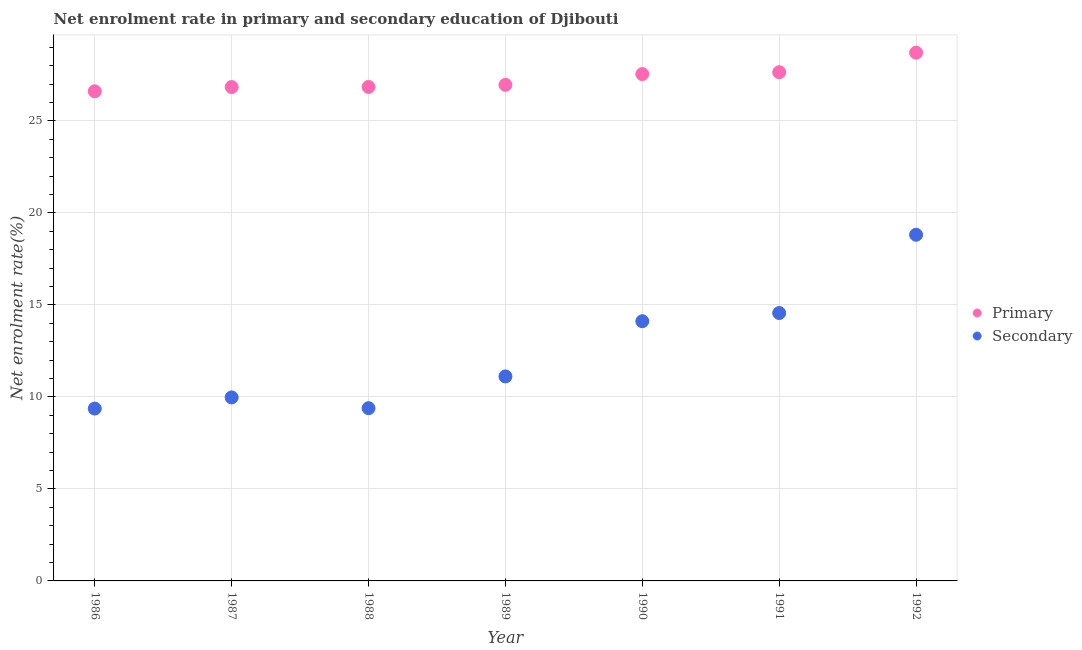What is the enrollment rate in primary education in 1988?
Provide a short and direct response. 26.84. Across all years, what is the maximum enrollment rate in secondary education?
Your response must be concise. 18.81. Across all years, what is the minimum enrollment rate in primary education?
Your answer should be compact. 26.61. What is the total enrollment rate in primary education in the graph?
Your answer should be compact. 191.12. What is the difference between the enrollment rate in primary education in 1986 and that in 1990?
Offer a very short reply. -0.94. What is the difference between the enrollment rate in primary education in 1990 and the enrollment rate in secondary education in 1991?
Provide a short and direct response. 12.98. What is the average enrollment rate in primary education per year?
Offer a terse response. 27.3. In the year 1989, what is the difference between the enrollment rate in secondary education and enrollment rate in primary education?
Offer a very short reply. -15.84. What is the ratio of the enrollment rate in primary education in 1986 to that in 1992?
Keep it short and to the point. 0.93. Is the difference between the enrollment rate in secondary education in 1989 and 1991 greater than the difference between the enrollment rate in primary education in 1989 and 1991?
Ensure brevity in your answer.  No. What is the difference between the highest and the second highest enrollment rate in secondary education?
Keep it short and to the point. 4.25. What is the difference between the highest and the lowest enrollment rate in primary education?
Give a very brief answer. 2.1. Is the enrollment rate in secondary education strictly less than the enrollment rate in primary education over the years?
Give a very brief answer. Yes. How many years are there in the graph?
Ensure brevity in your answer.  7. What is the difference between two consecutive major ticks on the Y-axis?
Offer a terse response. 5. Are the values on the major ticks of Y-axis written in scientific E-notation?
Your response must be concise. No. Does the graph contain any zero values?
Ensure brevity in your answer.  No. Does the graph contain grids?
Give a very brief answer. Yes. Where does the legend appear in the graph?
Your answer should be very brief. Center right. What is the title of the graph?
Your answer should be compact. Net enrolment rate in primary and secondary education of Djibouti. Does "Male" appear as one of the legend labels in the graph?
Give a very brief answer. No. What is the label or title of the X-axis?
Your response must be concise. Year. What is the label or title of the Y-axis?
Offer a terse response. Net enrolment rate(%). What is the Net enrolment rate(%) of Primary in 1986?
Provide a succinct answer. 26.61. What is the Net enrolment rate(%) in Secondary in 1986?
Your answer should be very brief. 9.37. What is the Net enrolment rate(%) in Primary in 1987?
Give a very brief answer. 26.84. What is the Net enrolment rate(%) in Secondary in 1987?
Make the answer very short. 9.97. What is the Net enrolment rate(%) in Primary in 1988?
Offer a terse response. 26.84. What is the Net enrolment rate(%) of Secondary in 1988?
Offer a very short reply. 9.39. What is the Net enrolment rate(%) of Primary in 1989?
Provide a succinct answer. 26.96. What is the Net enrolment rate(%) of Secondary in 1989?
Offer a terse response. 11.11. What is the Net enrolment rate(%) in Primary in 1990?
Your answer should be compact. 27.54. What is the Net enrolment rate(%) in Secondary in 1990?
Your response must be concise. 14.11. What is the Net enrolment rate(%) of Primary in 1991?
Offer a very short reply. 27.64. What is the Net enrolment rate(%) of Secondary in 1991?
Ensure brevity in your answer.  14.56. What is the Net enrolment rate(%) of Primary in 1992?
Provide a succinct answer. 28.7. What is the Net enrolment rate(%) in Secondary in 1992?
Your answer should be compact. 18.81. Across all years, what is the maximum Net enrolment rate(%) of Primary?
Keep it short and to the point. 28.7. Across all years, what is the maximum Net enrolment rate(%) in Secondary?
Make the answer very short. 18.81. Across all years, what is the minimum Net enrolment rate(%) in Primary?
Your response must be concise. 26.61. Across all years, what is the minimum Net enrolment rate(%) of Secondary?
Provide a succinct answer. 9.37. What is the total Net enrolment rate(%) in Primary in the graph?
Make the answer very short. 191.12. What is the total Net enrolment rate(%) of Secondary in the graph?
Ensure brevity in your answer.  87.32. What is the difference between the Net enrolment rate(%) in Primary in 1986 and that in 1987?
Your response must be concise. -0.23. What is the difference between the Net enrolment rate(%) of Secondary in 1986 and that in 1987?
Keep it short and to the point. -0.61. What is the difference between the Net enrolment rate(%) in Primary in 1986 and that in 1988?
Offer a very short reply. -0.24. What is the difference between the Net enrolment rate(%) of Secondary in 1986 and that in 1988?
Offer a very short reply. -0.02. What is the difference between the Net enrolment rate(%) in Primary in 1986 and that in 1989?
Ensure brevity in your answer.  -0.35. What is the difference between the Net enrolment rate(%) of Secondary in 1986 and that in 1989?
Your response must be concise. -1.75. What is the difference between the Net enrolment rate(%) of Primary in 1986 and that in 1990?
Keep it short and to the point. -0.94. What is the difference between the Net enrolment rate(%) of Secondary in 1986 and that in 1990?
Offer a very short reply. -4.75. What is the difference between the Net enrolment rate(%) of Primary in 1986 and that in 1991?
Give a very brief answer. -1.04. What is the difference between the Net enrolment rate(%) in Secondary in 1986 and that in 1991?
Provide a short and direct response. -5.19. What is the difference between the Net enrolment rate(%) in Primary in 1986 and that in 1992?
Offer a very short reply. -2.1. What is the difference between the Net enrolment rate(%) in Secondary in 1986 and that in 1992?
Provide a succinct answer. -9.44. What is the difference between the Net enrolment rate(%) of Primary in 1987 and that in 1988?
Provide a short and direct response. -0.01. What is the difference between the Net enrolment rate(%) in Secondary in 1987 and that in 1988?
Your answer should be compact. 0.58. What is the difference between the Net enrolment rate(%) in Primary in 1987 and that in 1989?
Provide a short and direct response. -0.12. What is the difference between the Net enrolment rate(%) in Secondary in 1987 and that in 1989?
Your response must be concise. -1.14. What is the difference between the Net enrolment rate(%) in Primary in 1987 and that in 1990?
Offer a very short reply. -0.7. What is the difference between the Net enrolment rate(%) of Secondary in 1987 and that in 1990?
Your response must be concise. -4.14. What is the difference between the Net enrolment rate(%) of Primary in 1987 and that in 1991?
Your answer should be very brief. -0.81. What is the difference between the Net enrolment rate(%) of Secondary in 1987 and that in 1991?
Provide a short and direct response. -4.58. What is the difference between the Net enrolment rate(%) in Primary in 1987 and that in 1992?
Make the answer very short. -1.87. What is the difference between the Net enrolment rate(%) in Secondary in 1987 and that in 1992?
Provide a short and direct response. -8.84. What is the difference between the Net enrolment rate(%) in Primary in 1988 and that in 1989?
Ensure brevity in your answer.  -0.11. What is the difference between the Net enrolment rate(%) in Secondary in 1988 and that in 1989?
Give a very brief answer. -1.73. What is the difference between the Net enrolment rate(%) in Primary in 1988 and that in 1990?
Give a very brief answer. -0.7. What is the difference between the Net enrolment rate(%) in Secondary in 1988 and that in 1990?
Your answer should be compact. -4.72. What is the difference between the Net enrolment rate(%) of Primary in 1988 and that in 1991?
Ensure brevity in your answer.  -0.8. What is the difference between the Net enrolment rate(%) in Secondary in 1988 and that in 1991?
Provide a succinct answer. -5.17. What is the difference between the Net enrolment rate(%) of Primary in 1988 and that in 1992?
Offer a very short reply. -1.86. What is the difference between the Net enrolment rate(%) in Secondary in 1988 and that in 1992?
Offer a terse response. -9.42. What is the difference between the Net enrolment rate(%) of Primary in 1989 and that in 1990?
Provide a succinct answer. -0.58. What is the difference between the Net enrolment rate(%) in Secondary in 1989 and that in 1990?
Offer a terse response. -3. What is the difference between the Net enrolment rate(%) in Primary in 1989 and that in 1991?
Provide a succinct answer. -0.69. What is the difference between the Net enrolment rate(%) of Secondary in 1989 and that in 1991?
Make the answer very short. -3.44. What is the difference between the Net enrolment rate(%) in Primary in 1989 and that in 1992?
Offer a very short reply. -1.75. What is the difference between the Net enrolment rate(%) of Secondary in 1989 and that in 1992?
Your answer should be compact. -7.7. What is the difference between the Net enrolment rate(%) of Primary in 1990 and that in 1991?
Your response must be concise. -0.1. What is the difference between the Net enrolment rate(%) of Secondary in 1990 and that in 1991?
Make the answer very short. -0.45. What is the difference between the Net enrolment rate(%) of Primary in 1990 and that in 1992?
Give a very brief answer. -1.16. What is the difference between the Net enrolment rate(%) of Secondary in 1990 and that in 1992?
Offer a terse response. -4.7. What is the difference between the Net enrolment rate(%) of Primary in 1991 and that in 1992?
Your answer should be compact. -1.06. What is the difference between the Net enrolment rate(%) of Secondary in 1991 and that in 1992?
Provide a succinct answer. -4.25. What is the difference between the Net enrolment rate(%) in Primary in 1986 and the Net enrolment rate(%) in Secondary in 1987?
Ensure brevity in your answer.  16.63. What is the difference between the Net enrolment rate(%) of Primary in 1986 and the Net enrolment rate(%) of Secondary in 1988?
Provide a succinct answer. 17.22. What is the difference between the Net enrolment rate(%) of Primary in 1986 and the Net enrolment rate(%) of Secondary in 1989?
Provide a succinct answer. 15.49. What is the difference between the Net enrolment rate(%) in Primary in 1986 and the Net enrolment rate(%) in Secondary in 1990?
Make the answer very short. 12.49. What is the difference between the Net enrolment rate(%) of Primary in 1986 and the Net enrolment rate(%) of Secondary in 1991?
Your response must be concise. 12.05. What is the difference between the Net enrolment rate(%) in Primary in 1986 and the Net enrolment rate(%) in Secondary in 1992?
Your answer should be compact. 7.8. What is the difference between the Net enrolment rate(%) of Primary in 1987 and the Net enrolment rate(%) of Secondary in 1988?
Make the answer very short. 17.45. What is the difference between the Net enrolment rate(%) of Primary in 1987 and the Net enrolment rate(%) of Secondary in 1989?
Offer a very short reply. 15.72. What is the difference between the Net enrolment rate(%) in Primary in 1987 and the Net enrolment rate(%) in Secondary in 1990?
Ensure brevity in your answer.  12.72. What is the difference between the Net enrolment rate(%) in Primary in 1987 and the Net enrolment rate(%) in Secondary in 1991?
Ensure brevity in your answer.  12.28. What is the difference between the Net enrolment rate(%) in Primary in 1987 and the Net enrolment rate(%) in Secondary in 1992?
Provide a short and direct response. 8.03. What is the difference between the Net enrolment rate(%) of Primary in 1988 and the Net enrolment rate(%) of Secondary in 1989?
Offer a terse response. 15.73. What is the difference between the Net enrolment rate(%) of Primary in 1988 and the Net enrolment rate(%) of Secondary in 1990?
Keep it short and to the point. 12.73. What is the difference between the Net enrolment rate(%) in Primary in 1988 and the Net enrolment rate(%) in Secondary in 1991?
Keep it short and to the point. 12.28. What is the difference between the Net enrolment rate(%) in Primary in 1988 and the Net enrolment rate(%) in Secondary in 1992?
Ensure brevity in your answer.  8.03. What is the difference between the Net enrolment rate(%) of Primary in 1989 and the Net enrolment rate(%) of Secondary in 1990?
Ensure brevity in your answer.  12.84. What is the difference between the Net enrolment rate(%) in Primary in 1989 and the Net enrolment rate(%) in Secondary in 1991?
Provide a short and direct response. 12.4. What is the difference between the Net enrolment rate(%) of Primary in 1989 and the Net enrolment rate(%) of Secondary in 1992?
Keep it short and to the point. 8.15. What is the difference between the Net enrolment rate(%) in Primary in 1990 and the Net enrolment rate(%) in Secondary in 1991?
Give a very brief answer. 12.98. What is the difference between the Net enrolment rate(%) in Primary in 1990 and the Net enrolment rate(%) in Secondary in 1992?
Your answer should be very brief. 8.73. What is the difference between the Net enrolment rate(%) in Primary in 1991 and the Net enrolment rate(%) in Secondary in 1992?
Make the answer very short. 8.83. What is the average Net enrolment rate(%) in Primary per year?
Make the answer very short. 27.3. What is the average Net enrolment rate(%) in Secondary per year?
Give a very brief answer. 12.47. In the year 1986, what is the difference between the Net enrolment rate(%) of Primary and Net enrolment rate(%) of Secondary?
Your answer should be compact. 17.24. In the year 1987, what is the difference between the Net enrolment rate(%) in Primary and Net enrolment rate(%) in Secondary?
Your answer should be compact. 16.86. In the year 1988, what is the difference between the Net enrolment rate(%) of Primary and Net enrolment rate(%) of Secondary?
Give a very brief answer. 17.45. In the year 1989, what is the difference between the Net enrolment rate(%) of Primary and Net enrolment rate(%) of Secondary?
Your answer should be very brief. 15.84. In the year 1990, what is the difference between the Net enrolment rate(%) of Primary and Net enrolment rate(%) of Secondary?
Ensure brevity in your answer.  13.43. In the year 1991, what is the difference between the Net enrolment rate(%) in Primary and Net enrolment rate(%) in Secondary?
Make the answer very short. 13.09. In the year 1992, what is the difference between the Net enrolment rate(%) in Primary and Net enrolment rate(%) in Secondary?
Offer a terse response. 9.89. What is the ratio of the Net enrolment rate(%) in Secondary in 1986 to that in 1987?
Provide a succinct answer. 0.94. What is the ratio of the Net enrolment rate(%) of Secondary in 1986 to that in 1988?
Provide a succinct answer. 1. What is the ratio of the Net enrolment rate(%) of Secondary in 1986 to that in 1989?
Ensure brevity in your answer.  0.84. What is the ratio of the Net enrolment rate(%) of Secondary in 1986 to that in 1990?
Make the answer very short. 0.66. What is the ratio of the Net enrolment rate(%) of Primary in 1986 to that in 1991?
Provide a succinct answer. 0.96. What is the ratio of the Net enrolment rate(%) in Secondary in 1986 to that in 1991?
Provide a short and direct response. 0.64. What is the ratio of the Net enrolment rate(%) of Primary in 1986 to that in 1992?
Your answer should be compact. 0.93. What is the ratio of the Net enrolment rate(%) in Secondary in 1986 to that in 1992?
Offer a terse response. 0.5. What is the ratio of the Net enrolment rate(%) of Primary in 1987 to that in 1988?
Ensure brevity in your answer.  1. What is the ratio of the Net enrolment rate(%) in Secondary in 1987 to that in 1988?
Offer a terse response. 1.06. What is the ratio of the Net enrolment rate(%) in Secondary in 1987 to that in 1989?
Provide a short and direct response. 0.9. What is the ratio of the Net enrolment rate(%) in Primary in 1987 to that in 1990?
Your answer should be compact. 0.97. What is the ratio of the Net enrolment rate(%) in Secondary in 1987 to that in 1990?
Provide a succinct answer. 0.71. What is the ratio of the Net enrolment rate(%) of Primary in 1987 to that in 1991?
Ensure brevity in your answer.  0.97. What is the ratio of the Net enrolment rate(%) in Secondary in 1987 to that in 1991?
Provide a succinct answer. 0.69. What is the ratio of the Net enrolment rate(%) in Primary in 1987 to that in 1992?
Provide a short and direct response. 0.93. What is the ratio of the Net enrolment rate(%) of Secondary in 1987 to that in 1992?
Offer a terse response. 0.53. What is the ratio of the Net enrolment rate(%) in Primary in 1988 to that in 1989?
Provide a short and direct response. 1. What is the ratio of the Net enrolment rate(%) of Secondary in 1988 to that in 1989?
Your response must be concise. 0.84. What is the ratio of the Net enrolment rate(%) of Primary in 1988 to that in 1990?
Your answer should be compact. 0.97. What is the ratio of the Net enrolment rate(%) of Secondary in 1988 to that in 1990?
Make the answer very short. 0.67. What is the ratio of the Net enrolment rate(%) of Primary in 1988 to that in 1991?
Your answer should be very brief. 0.97. What is the ratio of the Net enrolment rate(%) of Secondary in 1988 to that in 1991?
Your response must be concise. 0.64. What is the ratio of the Net enrolment rate(%) in Primary in 1988 to that in 1992?
Make the answer very short. 0.94. What is the ratio of the Net enrolment rate(%) in Secondary in 1988 to that in 1992?
Keep it short and to the point. 0.5. What is the ratio of the Net enrolment rate(%) in Primary in 1989 to that in 1990?
Your answer should be very brief. 0.98. What is the ratio of the Net enrolment rate(%) in Secondary in 1989 to that in 1990?
Keep it short and to the point. 0.79. What is the ratio of the Net enrolment rate(%) of Primary in 1989 to that in 1991?
Provide a short and direct response. 0.98. What is the ratio of the Net enrolment rate(%) of Secondary in 1989 to that in 1991?
Offer a very short reply. 0.76. What is the ratio of the Net enrolment rate(%) of Primary in 1989 to that in 1992?
Provide a short and direct response. 0.94. What is the ratio of the Net enrolment rate(%) in Secondary in 1989 to that in 1992?
Offer a terse response. 0.59. What is the ratio of the Net enrolment rate(%) in Secondary in 1990 to that in 1991?
Offer a terse response. 0.97. What is the ratio of the Net enrolment rate(%) of Primary in 1990 to that in 1992?
Offer a terse response. 0.96. What is the ratio of the Net enrolment rate(%) of Secondary in 1990 to that in 1992?
Provide a succinct answer. 0.75. What is the ratio of the Net enrolment rate(%) in Secondary in 1991 to that in 1992?
Your response must be concise. 0.77. What is the difference between the highest and the second highest Net enrolment rate(%) in Primary?
Your answer should be very brief. 1.06. What is the difference between the highest and the second highest Net enrolment rate(%) in Secondary?
Make the answer very short. 4.25. What is the difference between the highest and the lowest Net enrolment rate(%) of Primary?
Make the answer very short. 2.1. What is the difference between the highest and the lowest Net enrolment rate(%) in Secondary?
Provide a succinct answer. 9.44. 